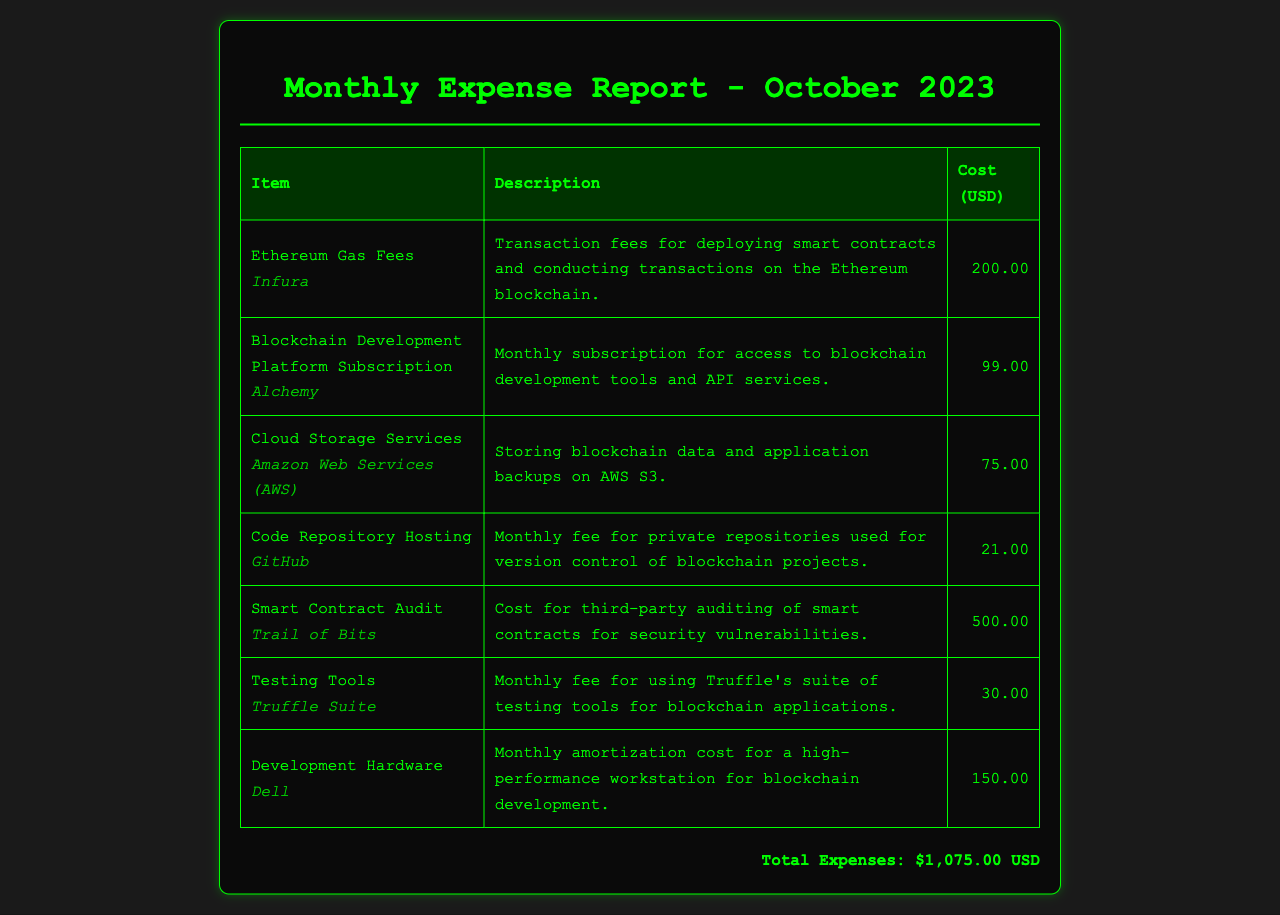What is the total expense for October 2023? The total expense is reported at the bottom of the document, summing all individual expenses.
Answer: $1,075.00 USD How much is the monthly subscription for Alchemy? The document lists the cost of the Alchemy subscription as part of the itemized expenses.
Answer: $99.00 Which provider offers the smart contract audit? The provider for the audit service is specified in the item description in the document.
Answer: Trail of Bits What is the purpose of the expenses listed for AWS? The document describes the purpose of AWS expenses related to blockchain data storage.
Answer: Storing blockchain data and application backups What is the cost for hosting private repositories on GitHub? The cost for GitHub is mentioned under the item for code repository hosting.
Answer: $21.00 How many fees are related to development hardware? The document specifies one fee related to development hardware costs.
Answer: One What is the total cost for Ethereum gas fees? The document provides the exact cost for Ethereum gas fees under the respective item.
Answer: $200.00 Which testing tools are mentioned in the report? The item for testing tools lists the specific tools used for blockchain applications.
Answer: Truffle Suite 